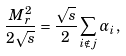Convert formula to latex. <formula><loc_0><loc_0><loc_500><loc_500>\frac { M _ { r } ^ { 2 } } { 2 \sqrt { s } } = \frac { \sqrt { s } } { 2 } \sum _ { i \notin j } \alpha _ { i } \, ,</formula> 